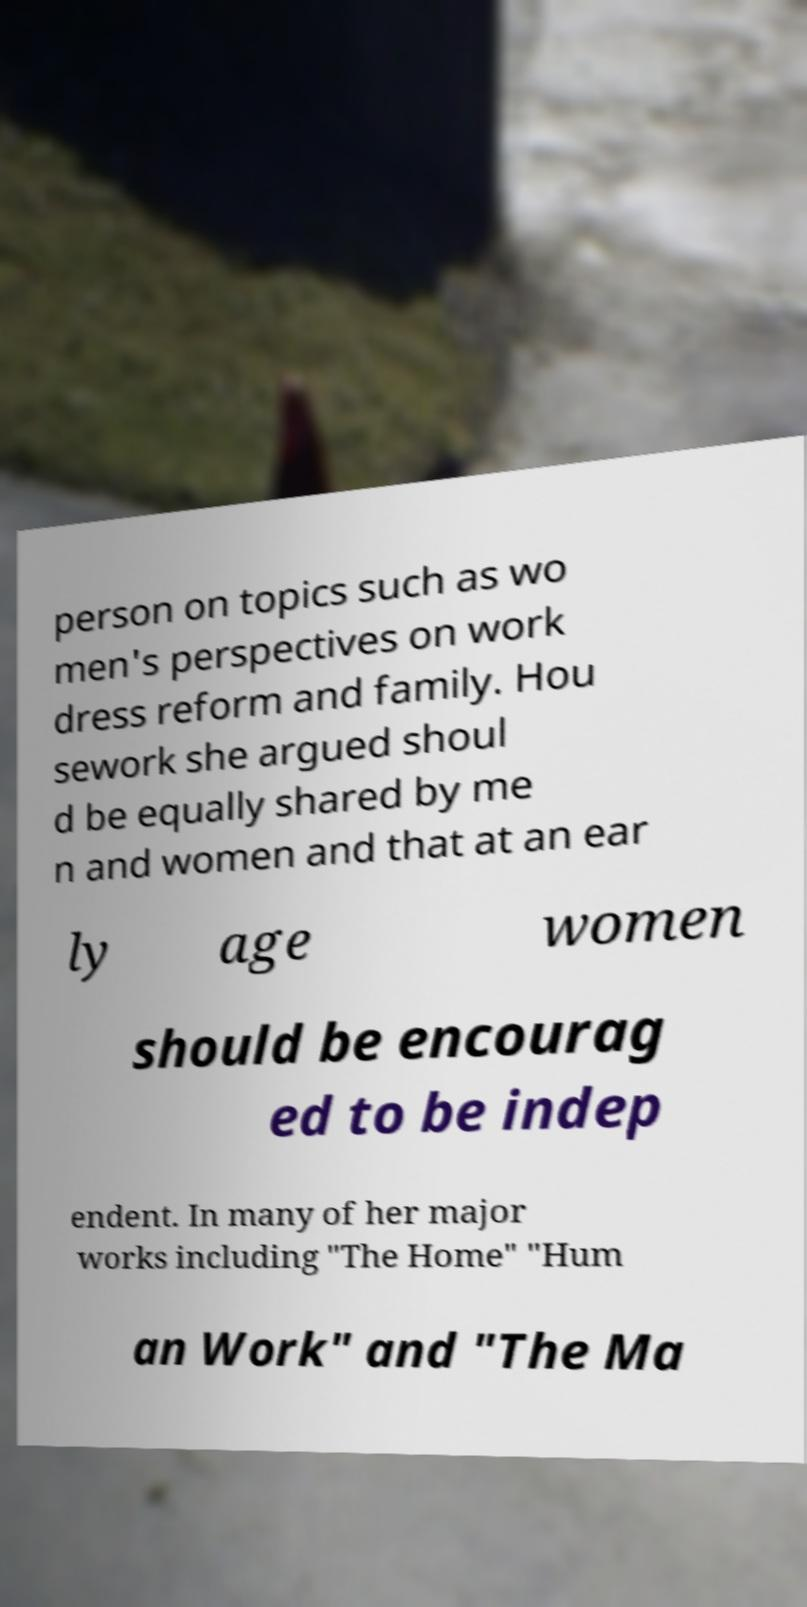Can you accurately transcribe the text from the provided image for me? person on topics such as wo men's perspectives on work dress reform and family. Hou sework she argued shoul d be equally shared by me n and women and that at an ear ly age women should be encourag ed to be indep endent. In many of her major works including "The Home" "Hum an Work" and "The Ma 